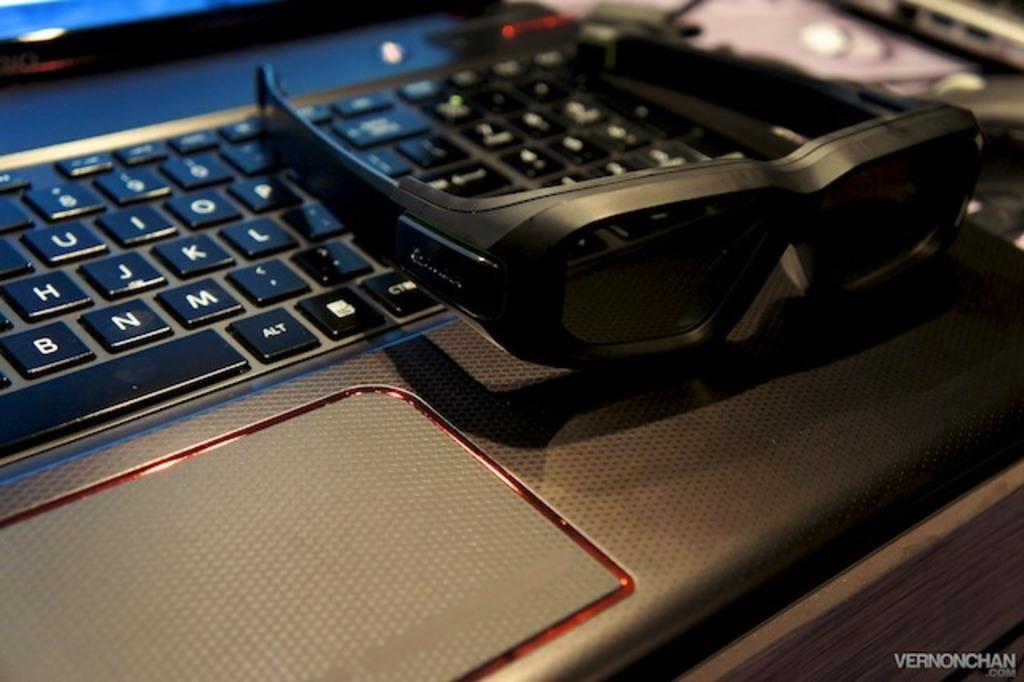What key is next to the space bar?
Provide a succinct answer. Alt. Alt keyboard key?
Your response must be concise. Yes. 